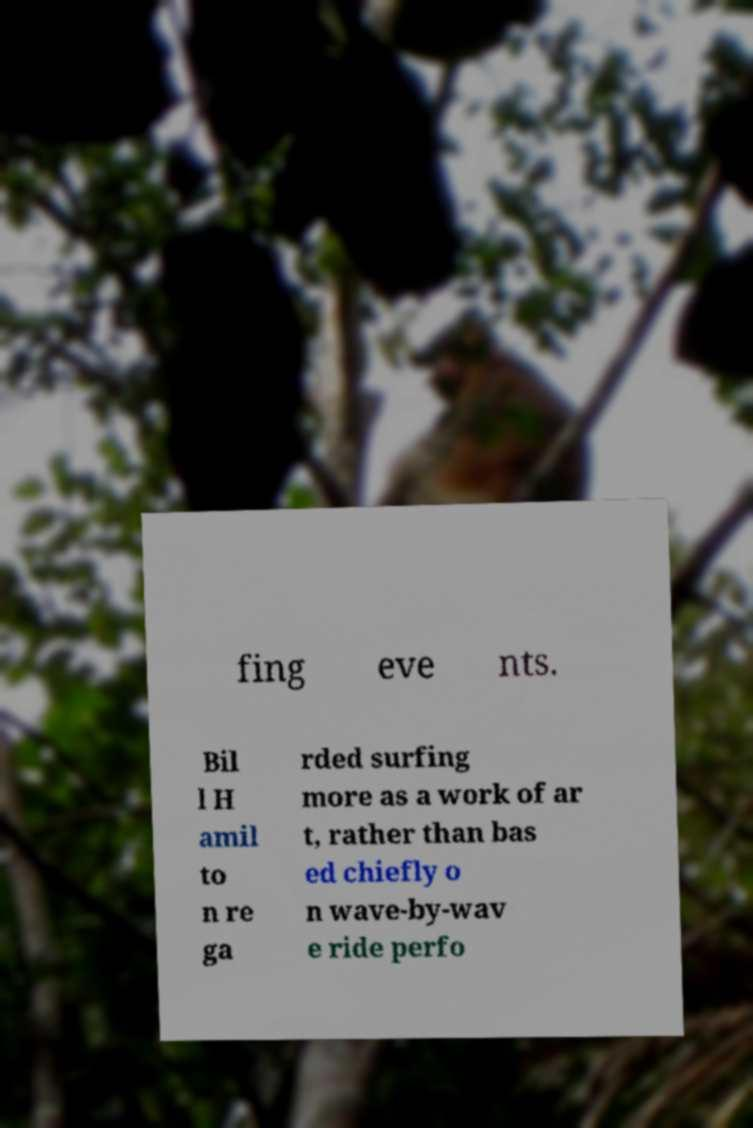Could you extract and type out the text from this image? fing eve nts. Bil l H amil to n re ga rded surfing more as a work of ar t, rather than bas ed chiefly o n wave-by-wav e ride perfo 